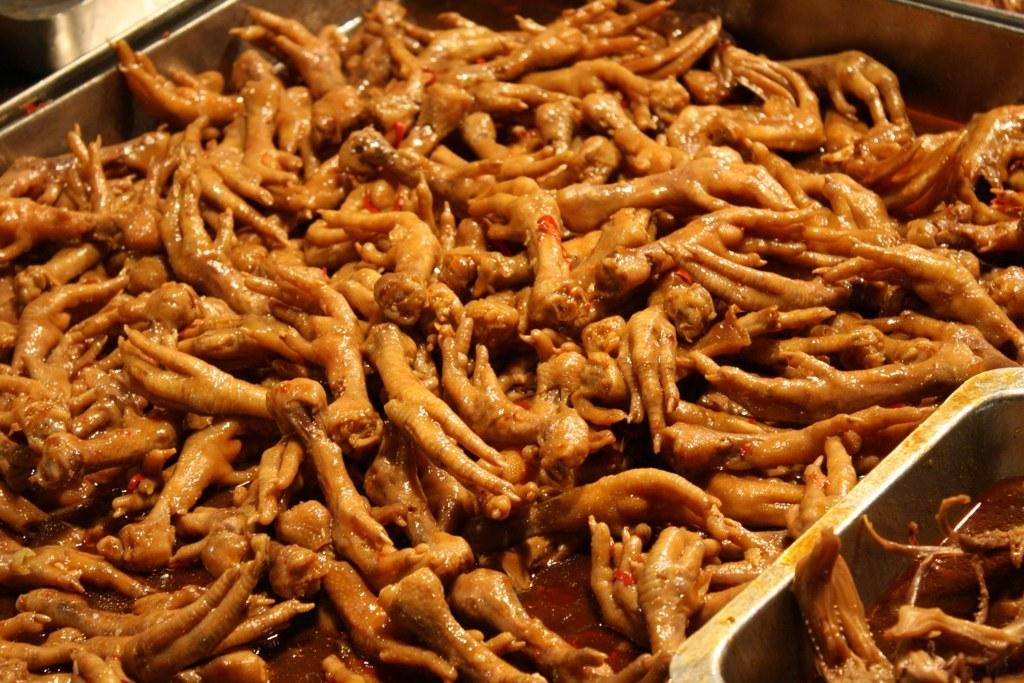What type of animal legs can be seen in the image? The legs of birds can be seen in the image. Where are the legs of birds located? The legs of birds are in bowls. What type of peace agreement is being discussed in the image? There is no peace agreement or discussion present in the image; it features the legs of birds in bowls. What subject is being taught in the image? A: There is no teaching or educational context present in the image; it features the legs of birds in bowls. 